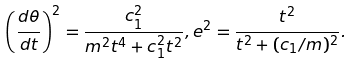<formula> <loc_0><loc_0><loc_500><loc_500>\left ( \frac { d \theta } { d t } \right ) ^ { 2 } = \frac { c _ { 1 } ^ { 2 } } { m ^ { 2 } t ^ { 4 } + c _ { 1 } ^ { 2 } t ^ { 2 } } , e ^ { 2 } = \frac { t ^ { 2 } } { t ^ { 2 } + ( c _ { 1 } / m ) ^ { 2 } } .</formula> 